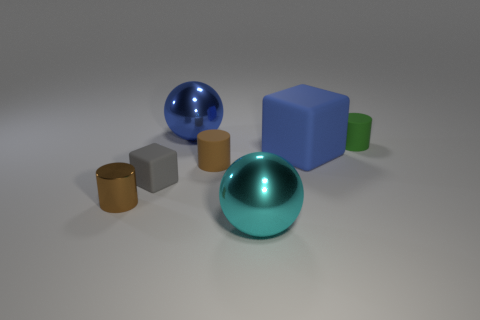Are there any blue metal objects that are on the right side of the big blue rubber cube that is behind the cyan shiny object?
Offer a very short reply. No. Does the shiny object behind the green cylinder have the same shape as the small matte object that is right of the large cyan metal sphere?
Provide a succinct answer. No. Is the material of the blue thing behind the small green cylinder the same as the cylinder right of the large blue matte object?
Your answer should be very brief. No. What material is the small cylinder that is behind the blue object in front of the green matte object made of?
Offer a very short reply. Rubber. What is the shape of the brown object to the left of the blue thing left of the big metal thing in front of the green cylinder?
Give a very brief answer. Cylinder. There is another small brown object that is the same shape as the tiny brown metal object; what is its material?
Your answer should be very brief. Rubber. How many tiny green things are there?
Make the answer very short. 1. There is a small brown object behind the tiny gray block; what is its shape?
Ensure brevity in your answer.  Cylinder. There is a sphere that is behind the large shiny object that is in front of the shiny sphere that is behind the brown metal cylinder; what color is it?
Provide a short and direct response. Blue. What is the shape of the green thing that is the same material as the large blue cube?
Provide a short and direct response. Cylinder. 